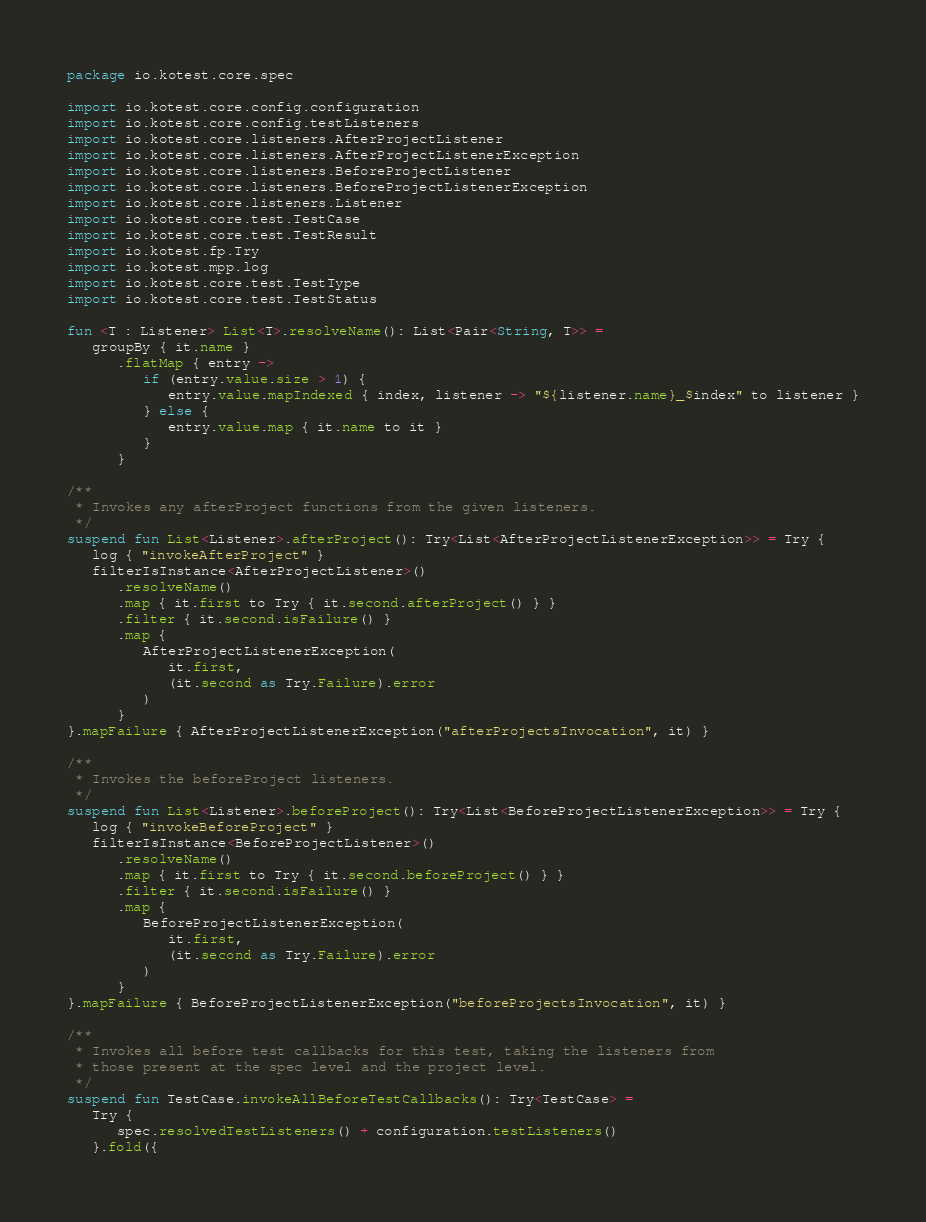<code> <loc_0><loc_0><loc_500><loc_500><_Kotlin_>package io.kotest.core.spec

import io.kotest.core.config.configuration
import io.kotest.core.config.testListeners
import io.kotest.core.listeners.AfterProjectListener
import io.kotest.core.listeners.AfterProjectListenerException
import io.kotest.core.listeners.BeforeProjectListener
import io.kotest.core.listeners.BeforeProjectListenerException
import io.kotest.core.listeners.Listener
import io.kotest.core.test.TestCase
import io.kotest.core.test.TestResult
import io.kotest.fp.Try
import io.kotest.mpp.log
import io.kotest.core.test.TestType
import io.kotest.core.test.TestStatus

fun <T : Listener> List<T>.resolveName(): List<Pair<String, T>> =
   groupBy { it.name }
      .flatMap { entry ->
         if (entry.value.size > 1) {
            entry.value.mapIndexed { index, listener -> "${listener.name}_$index" to listener }
         } else {
            entry.value.map { it.name to it }
         }
      }

/**
 * Invokes any afterProject functions from the given listeners.
 */
suspend fun List<Listener>.afterProject(): Try<List<AfterProjectListenerException>> = Try {
   log { "invokeAfterProject" }
   filterIsInstance<AfterProjectListener>()
      .resolveName()
      .map { it.first to Try { it.second.afterProject() } }
      .filter { it.second.isFailure() }
      .map {
         AfterProjectListenerException(
            it.first,
            (it.second as Try.Failure).error
         )
      }
}.mapFailure { AfterProjectListenerException("afterProjectsInvocation", it) }

/**
 * Invokes the beforeProject listeners.
 */
suspend fun List<Listener>.beforeProject(): Try<List<BeforeProjectListenerException>> = Try {
   log { "invokeBeforeProject" }
   filterIsInstance<BeforeProjectListener>()
      .resolveName()
      .map { it.first to Try { it.second.beforeProject() } }
      .filter { it.second.isFailure() }
      .map {
         BeforeProjectListenerException(
            it.first,
            (it.second as Try.Failure).error
         )
      }
}.mapFailure { BeforeProjectListenerException("beforeProjectsInvocation", it) }

/**
 * Invokes all before test callbacks for this test, taking the listeners from
 * those present at the spec level and the project level.
 */
suspend fun TestCase.invokeAllBeforeTestCallbacks(): Try<TestCase> =
   Try {
      spec.resolvedTestListeners() + configuration.testListeners()
   }.fold({</code> 